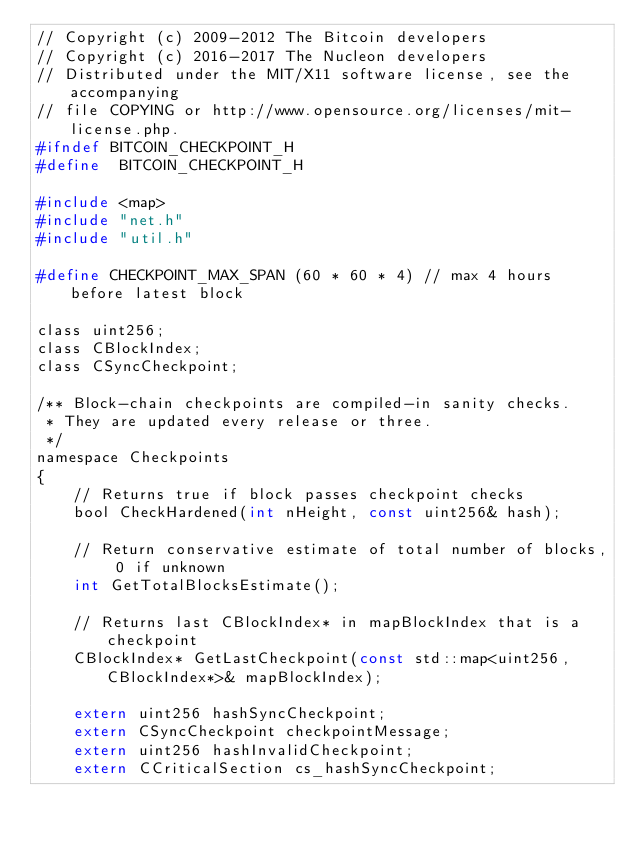<code> <loc_0><loc_0><loc_500><loc_500><_C_>// Copyright (c) 2009-2012 The Bitcoin developers
// Copyright (c) 2016-2017 The Nucleon developers
// Distributed under the MIT/X11 software license, see the accompanying
// file COPYING or http://www.opensource.org/licenses/mit-license.php.
#ifndef BITCOIN_CHECKPOINT_H
#define  BITCOIN_CHECKPOINT_H

#include <map>
#include "net.h"
#include "util.h"

#define CHECKPOINT_MAX_SPAN (60 * 60 * 4) // max 4 hours before latest block

class uint256;
class CBlockIndex;
class CSyncCheckpoint;

/** Block-chain checkpoints are compiled-in sanity checks.
 * They are updated every release or three.
 */
namespace Checkpoints
{
    // Returns true if block passes checkpoint checks
    bool CheckHardened(int nHeight, const uint256& hash);

    // Return conservative estimate of total number of blocks, 0 if unknown
    int GetTotalBlocksEstimate();

    // Returns last CBlockIndex* in mapBlockIndex that is a checkpoint
    CBlockIndex* GetLastCheckpoint(const std::map<uint256, CBlockIndex*>& mapBlockIndex);

    extern uint256 hashSyncCheckpoint;
    extern CSyncCheckpoint checkpointMessage;
    extern uint256 hashInvalidCheckpoint;
    extern CCriticalSection cs_hashSyncCheckpoint;
</code> 